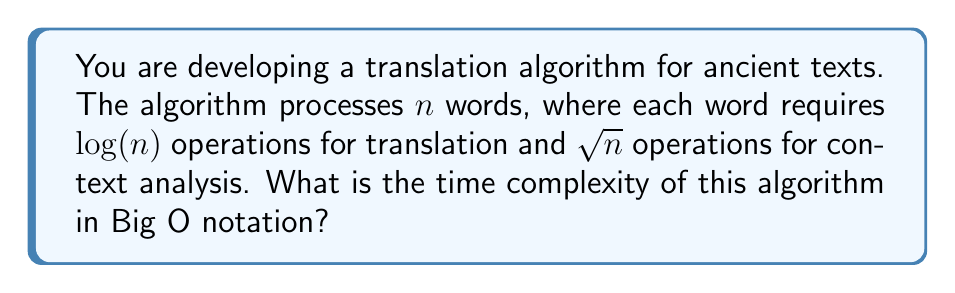Help me with this question. Let's approach this step-by-step:

1) For each word, the algorithm performs two operations:
   a) Translation: $\log(n)$ operations
   b) Context analysis: $\sqrt{n}$ operations

2) The total operations for one word:
   $\log(n) + \sqrt{n}$

3) Since there are $n$ words, we multiply this by $n$:
   $n(\log(n) + \sqrt{n})$

4) Expanding the brackets:
   $n\log(n) + n\sqrt{n}$

5) In Big O notation, we only consider the dominant term as $n$ approaches infinity. To determine which term is dominant, we can compare their growth rates:

   $\lim_{n \to \infty} \frac{n\log(n)}{n\sqrt{n}} = \lim_{n \to \infty} \frac{\log(n)}{\sqrt{n}} = 0$

6) This limit approaching 0 indicates that $n\sqrt{n}$ grows faster than $n\log(n)$ for large $n$.

7) Therefore, the dominant term is $n\sqrt{n}$, which can be written as $n^{1.5}$.

Thus, the time complexity of the algorithm is $O(n^{1.5})$.
Answer: $O(n^{1.5})$ 